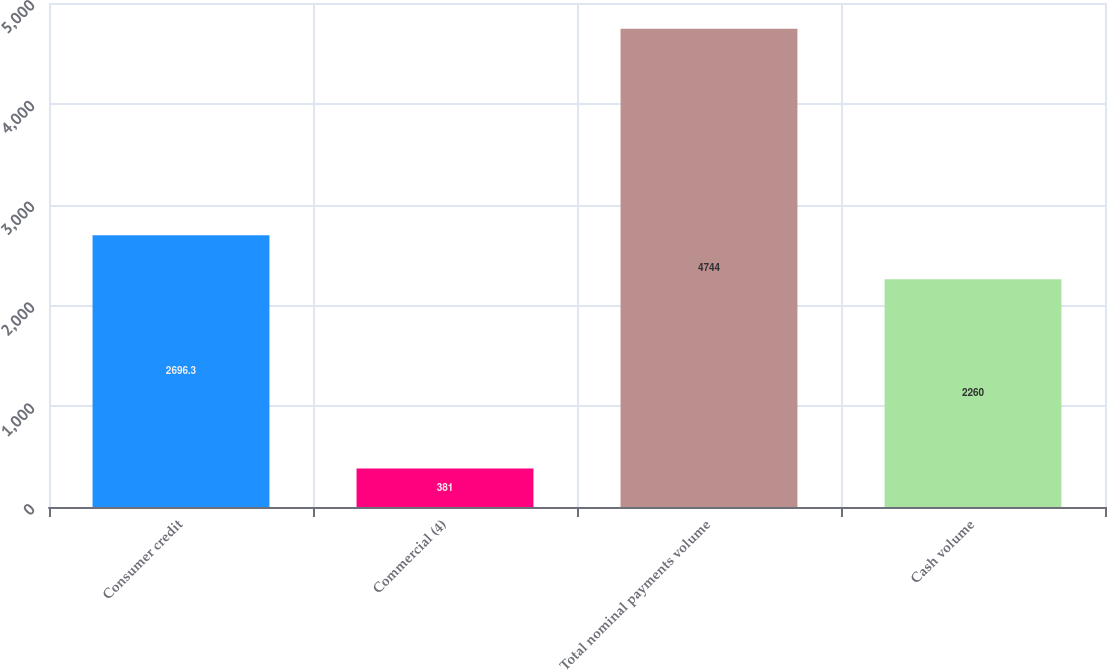Convert chart. <chart><loc_0><loc_0><loc_500><loc_500><bar_chart><fcel>Consumer credit<fcel>Commercial (4)<fcel>Total nominal payments volume<fcel>Cash volume<nl><fcel>2696.3<fcel>381<fcel>4744<fcel>2260<nl></chart> 